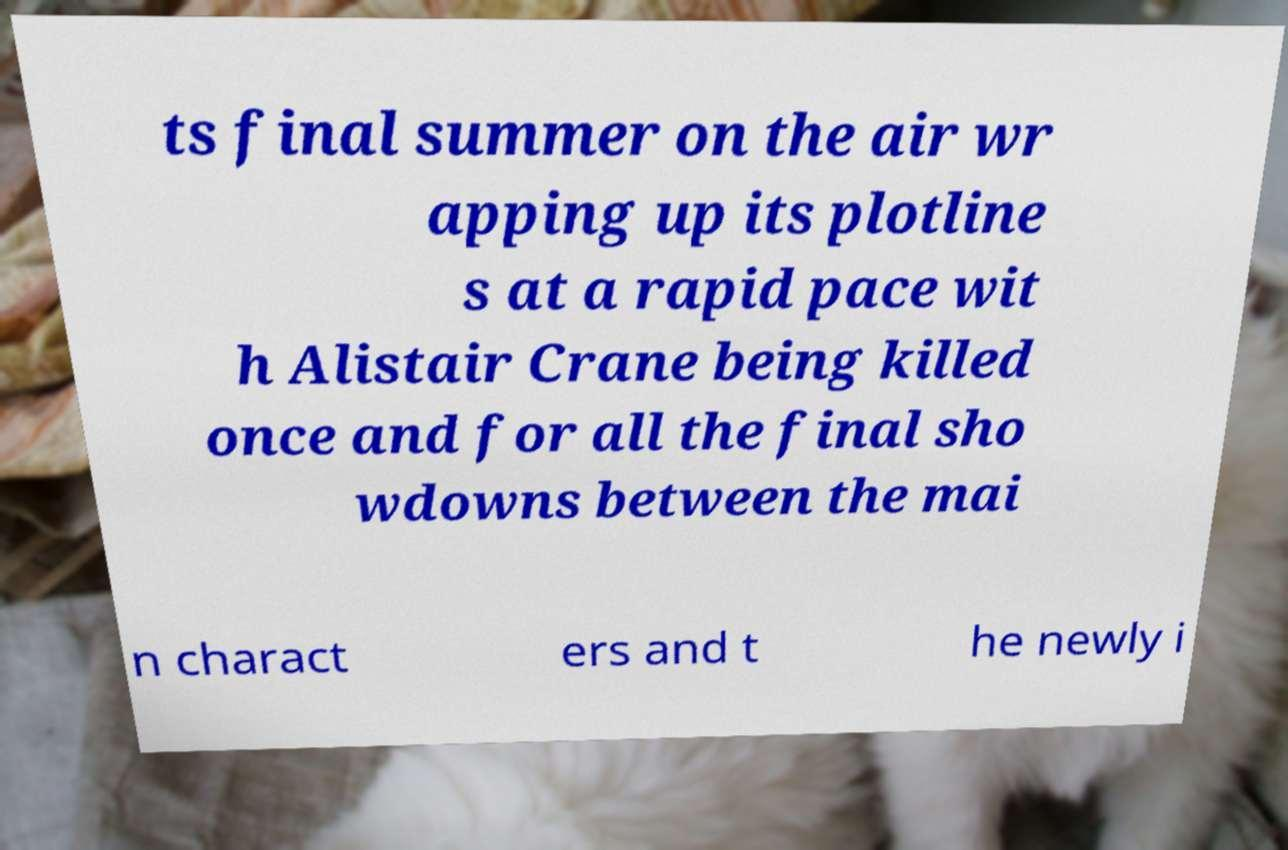Can you read and provide the text displayed in the image?This photo seems to have some interesting text. Can you extract and type it out for me? ts final summer on the air wr apping up its plotline s at a rapid pace wit h Alistair Crane being killed once and for all the final sho wdowns between the mai n charact ers and t he newly i 